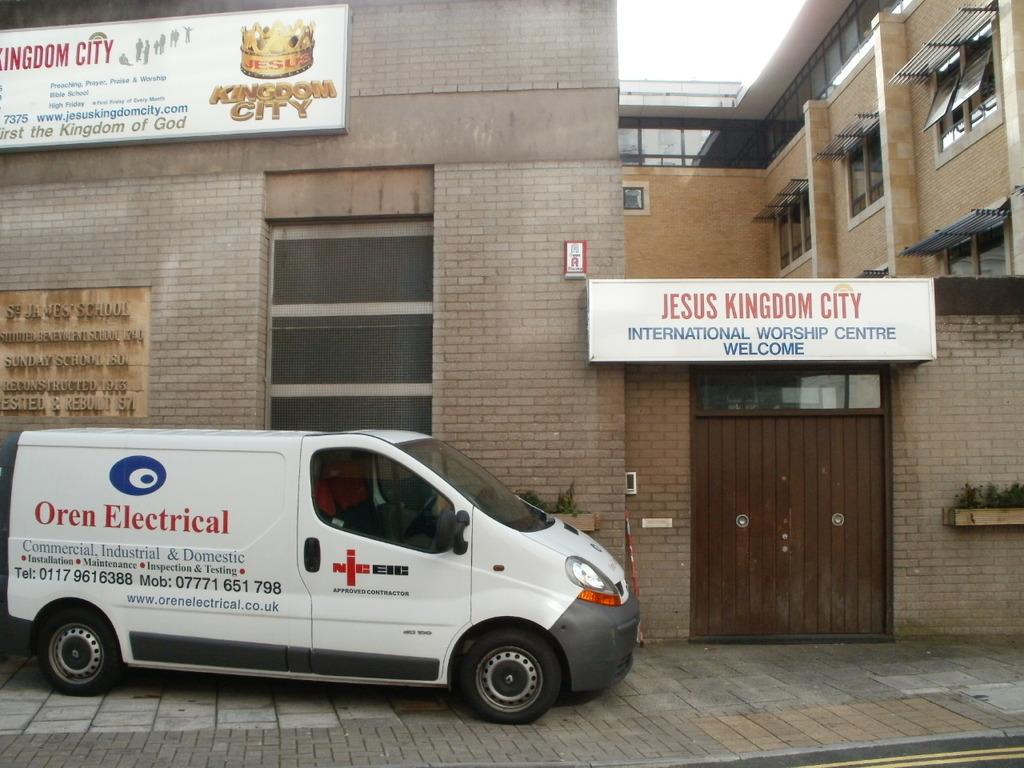What electrical company is the van from?
Your answer should be compact. Oren electrical. What is the sign welcoming people to?
Give a very brief answer. Jesus kingdom city. 